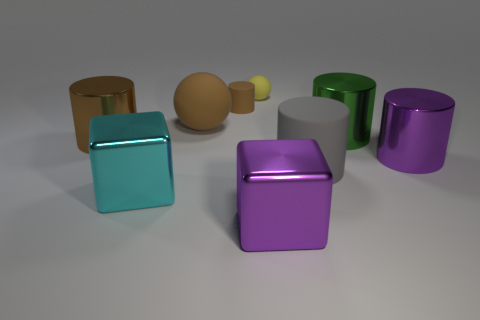Subtract all big cylinders. How many cylinders are left? 1 Subtract all purple cubes. How many brown cylinders are left? 2 Subtract 3 cylinders. How many cylinders are left? 2 Subtract all green cylinders. How many cylinders are left? 4 Subtract all green cylinders. Subtract all red blocks. How many cylinders are left? 4 Subtract all cubes. How many objects are left? 7 Add 4 brown rubber cubes. How many brown rubber cubes exist? 4 Subtract 1 green cylinders. How many objects are left? 8 Subtract all green metal cylinders. Subtract all tiny yellow balls. How many objects are left? 7 Add 9 cyan cubes. How many cyan cubes are left? 10 